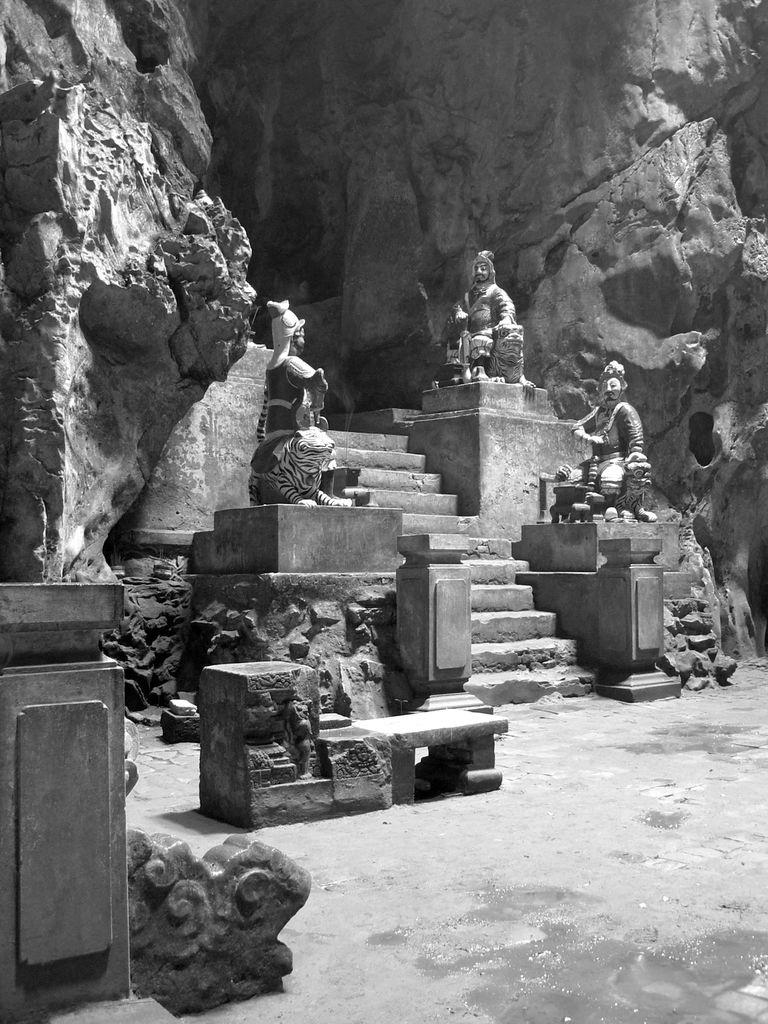What is the color scheme of the image? The image is black and white. What type of objects can be seen in the image? There are statues in the image. What architectural feature is present in the image? There are steps in the image. What type of natural elements are visible in the image? Rocks are present in the image. What is the surface that the statues and steps are placed on? The ground is visible in the image. What type of pin is being used to hold the car in place in the image? There is no car present in the image, so there is no need for a pin to hold it in place. 